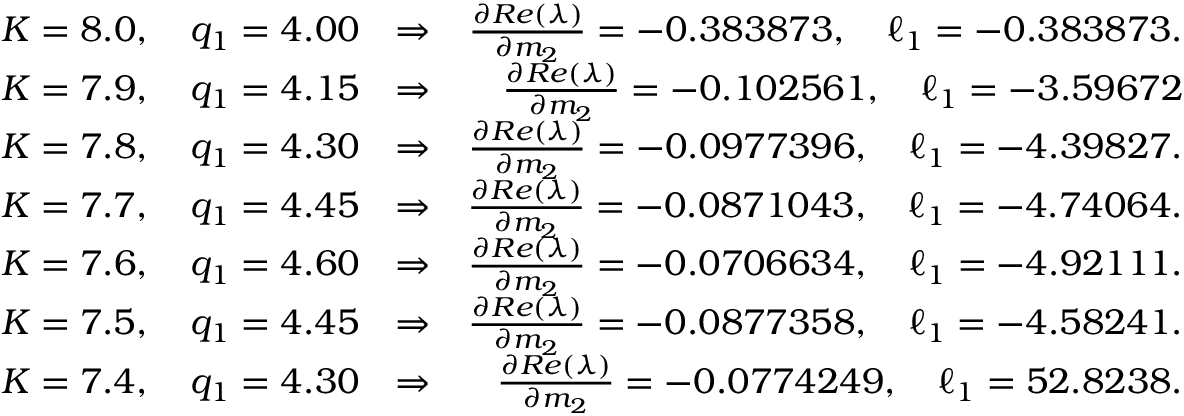Convert formula to latex. <formula><loc_0><loc_0><loc_500><loc_500>\begin{array} { r l r } { K = 8 . 0 , \quad q _ { 1 } = 4 . 0 0 } & { \Rightarrow } & { \frac { \partial R e ( \lambda ) } { \partial m _ { 2 } } = - 0 . 3 8 3 8 7 3 , \quad \ell _ { 1 } = - 0 . 3 8 3 8 7 3 . } \\ { K = 7 . 9 , \quad q _ { 1 } = 4 . 1 5 } & { \Rightarrow } & { \frac { \partial R e ( \lambda ) } { \partial m _ { 2 } } = - 0 . 1 0 2 5 6 1 , \quad \ell _ { 1 } = - 3 . 5 9 6 7 2 } \\ { K = 7 . 8 , \quad q _ { 1 } = 4 . 3 0 } & { \Rightarrow } & { \frac { \partial R e ( \lambda ) } { \partial m _ { 2 } } = - 0 . 0 9 7 7 3 9 6 , \quad \ell _ { 1 } = - 4 . 3 9 8 2 7 . } \\ { K = 7 . 7 , \quad q _ { 1 } = 4 . 4 5 } & { \Rightarrow } & { \frac { \partial R e ( \lambda ) } { \partial m _ { 2 } } = - 0 . 0 8 7 1 0 4 3 , \quad \ell _ { 1 } = - 4 . 7 4 0 6 4 . } \\ { K = 7 . 6 , \quad q _ { 1 } = 4 . 6 0 } & { \Rightarrow } & { \frac { \partial R e ( \lambda ) } { \partial m _ { 2 } } = - 0 . 0 7 0 6 6 3 4 , \quad \ell _ { 1 } = - 4 . 9 2 1 1 1 . } \\ { K = 7 . 5 , \quad q _ { 1 } = 4 . 4 5 } & { \Rightarrow } & { \frac { \partial R e ( \lambda ) } { \partial m _ { 2 } } = - 0 . 0 8 7 7 3 5 8 , \quad \ell _ { 1 } = - 4 . 5 8 2 4 1 . } \\ { K = 7 . 4 , \quad q _ { 1 } = 4 . 3 0 } & { \Rightarrow } & { \frac { \partial R e ( \lambda ) } { \partial m _ { 2 } } = - 0 . 0 7 7 4 2 4 9 , \quad \ell _ { 1 } = 5 2 . 8 2 3 8 . } \end{array}</formula> 